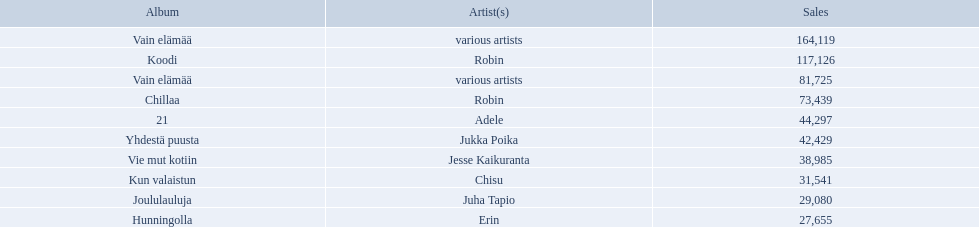What are all the album titles? Vain elämää, Koodi, Vain elämää, Chillaa, 21, Yhdestä puusta, Vie mut kotiin, Kun valaistun, Joululauluja, Hunningolla. Which artists were on the albums? Various artists, robin, various artists, robin, adele, jukka poika, jesse kaikuranta, chisu, juha tapio, erin. Along with chillaa, which other album featured robin? Koodi. 